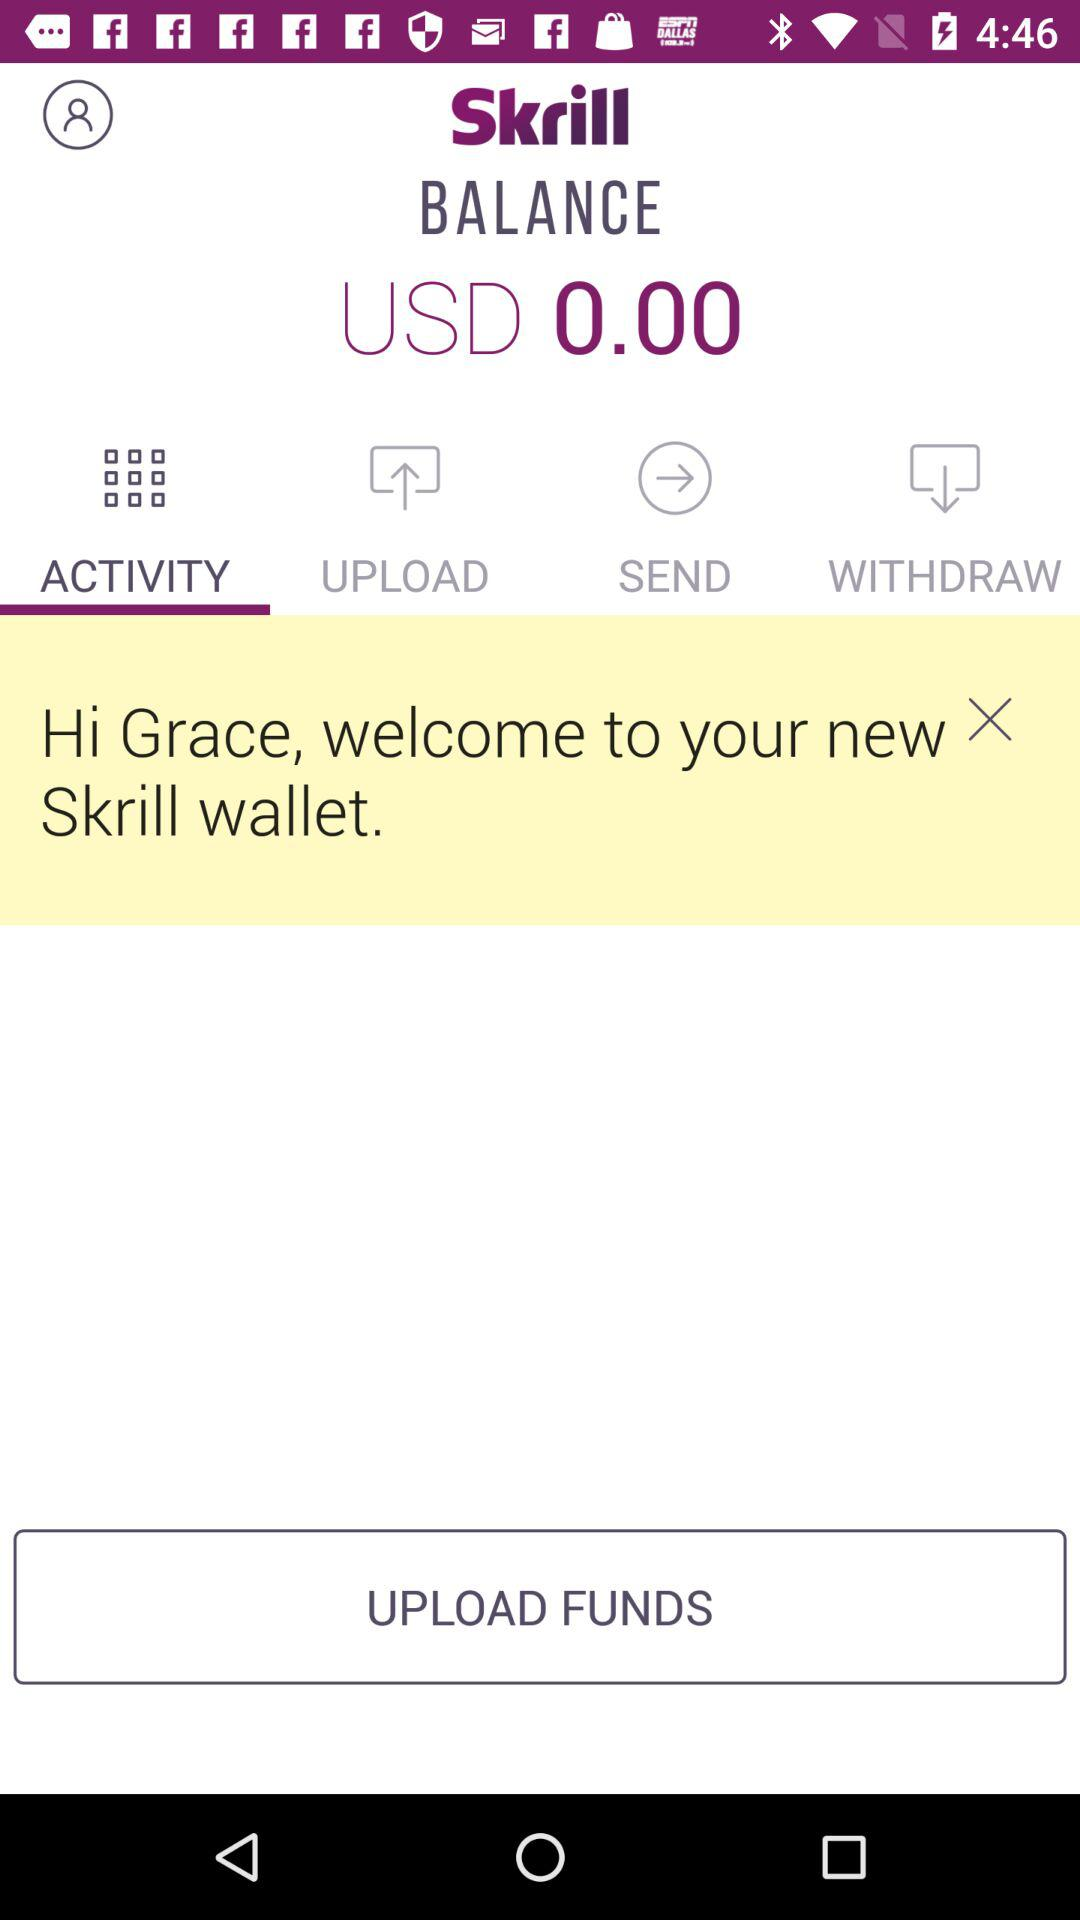What is the remaining balance? The remaining balance is USD 0.00. 